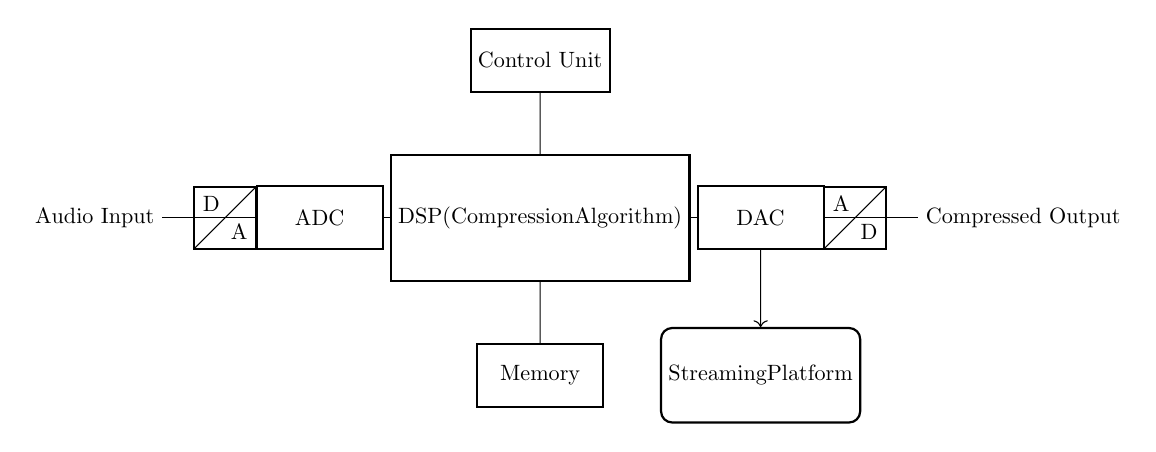What component converts the audio input to digital signals? The component that performs this function is the ADC (Analog to Digital Converter), which is clearly labeled in the circuit diagram and connected to the audio input.
Answer: ADC What is the main function of the DSP in this circuit? The DSP (Digital Signal Processor) applies the compression algorithm to the audio signals it receives from the ADC. This is indicated in the circuit by its labeling and connection to the ADC.
Answer: Compression How many memory modules are present in the circuit? There is one memory module in the circuit, as shown by the single labeled block for memory positioned below the DSP.
Answer: One What does the DAC do in this circuit? The DAC (Digital to Analog Converter) converts the processed digital signals back into analog signals for output, as indicated by its position after the DSP in the circuit.
Answer: Converts digital to analog Which component connects the DAC to the streaming platform? The connection from the DAC to the streaming platform is represented by a directed arrow, signifying the flow of audio data. This connection clearly shows the DAC leading to the streaming platform.
Answer: DAC Where is the control unit located in the circuit? The control unit is located above the DSP, as indicated in the circuit diagram, showing its hierarchical arrangement in relation to the DSP.
Answer: Above the DSP What is the output of the circuit labeled as? The output is labeled as "Compressed Output," indicating the final result of the audio signal processing. This is explicitly marked in the diagram near the end of the circuit.
Answer: Compressed Output 